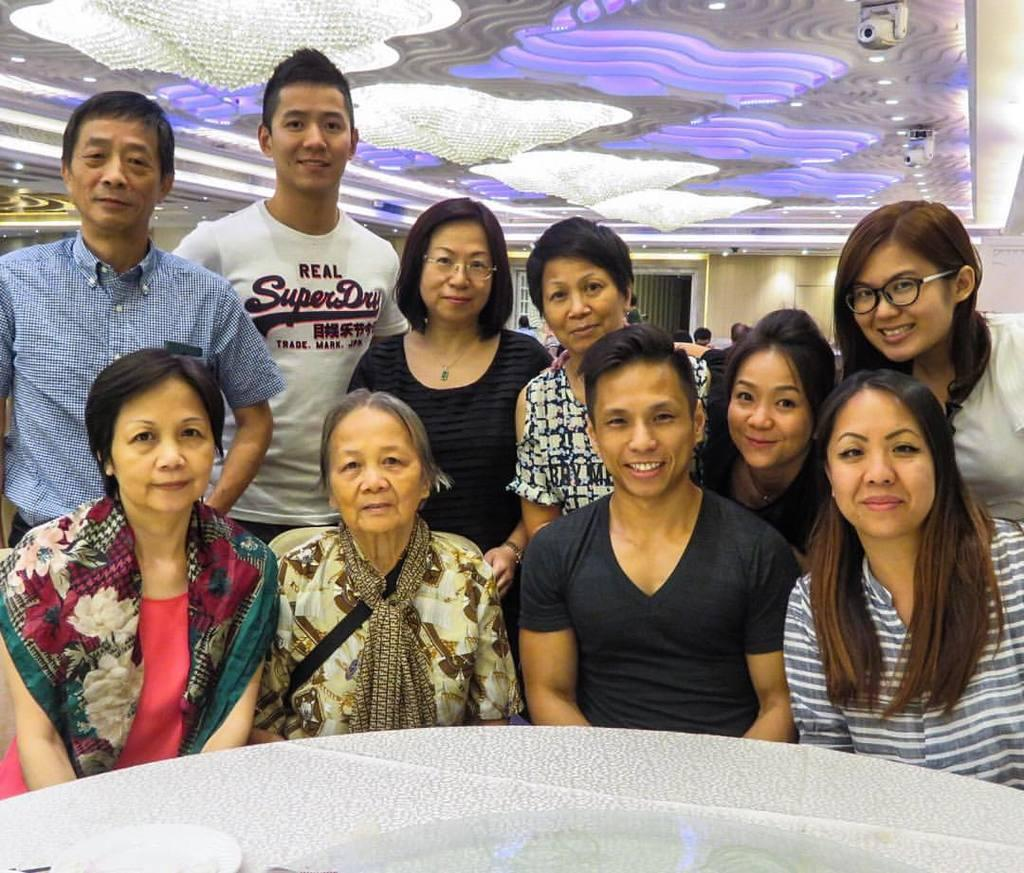Who or what is present in the image? There are people in the image. What is the facial expression of the people in the image? The people are smiling. What object can be seen on the table in the image? There is a plate on the table. What can be seen at the top of the image? There are lights visible at the top of the image. What is visible in the background of the image? There is a wall and people in the background of the image. What is the weight of the cakes on the table in the image? There are no cakes present in the image, so it is not possible to determine their weight. 